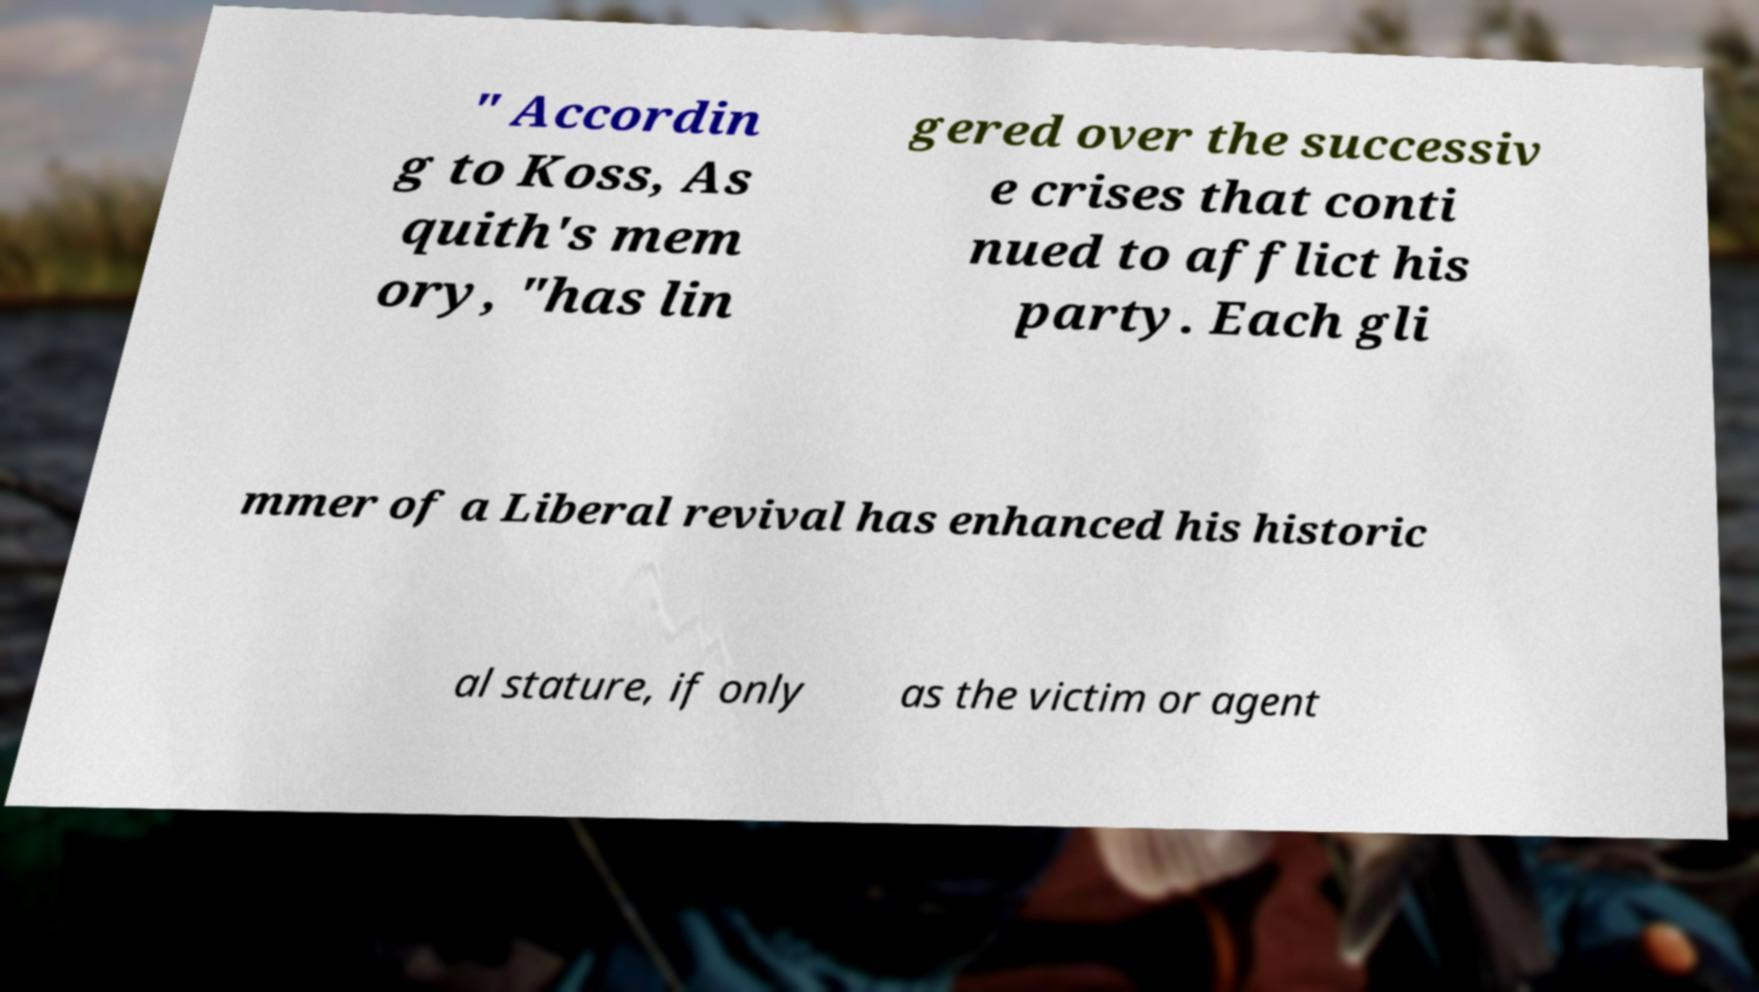Can you read and provide the text displayed in the image?This photo seems to have some interesting text. Can you extract and type it out for me? " Accordin g to Koss, As quith's mem ory, "has lin gered over the successiv e crises that conti nued to afflict his party. Each gli mmer of a Liberal revival has enhanced his historic al stature, if only as the victim or agent 